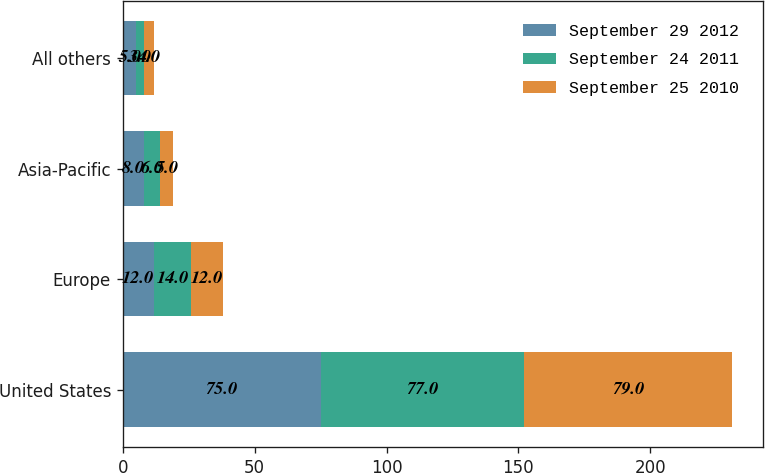Convert chart to OTSL. <chart><loc_0><loc_0><loc_500><loc_500><stacked_bar_chart><ecel><fcel>United States<fcel>Europe<fcel>Asia-Pacific<fcel>All others<nl><fcel>September 29 2012<fcel>75<fcel>12<fcel>8<fcel>5<nl><fcel>September 24 2011<fcel>77<fcel>14<fcel>6<fcel>3<nl><fcel>September 25 2010<fcel>79<fcel>12<fcel>5<fcel>4<nl></chart> 